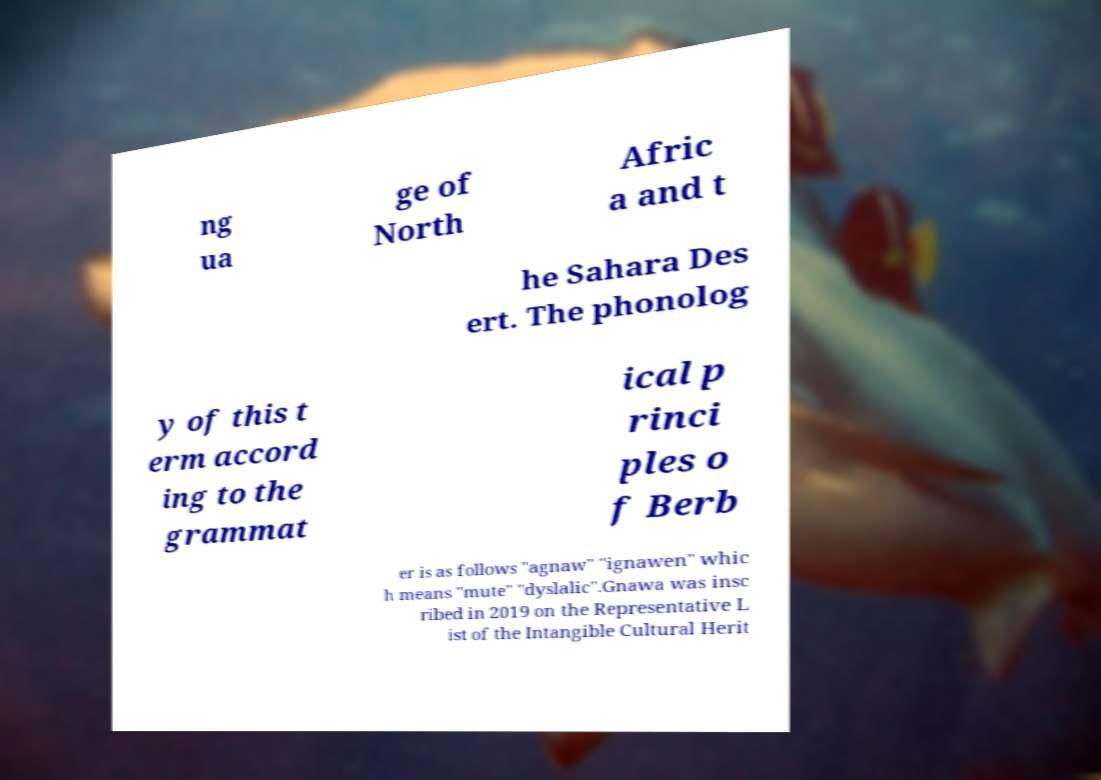There's text embedded in this image that I need extracted. Can you transcribe it verbatim? ng ua ge of North Afric a and t he Sahara Des ert. The phonolog y of this t erm accord ing to the grammat ical p rinci ples o f Berb er is as follows "agnaw" "ignawen" whic h means "mute" "dyslalic".Gnawa was insc ribed in 2019 on the Representative L ist of the Intangible Cultural Herit 